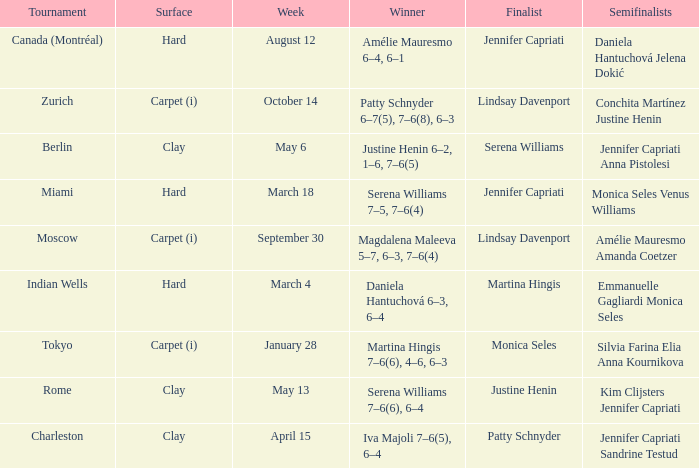What week was the finalist Martina Hingis? March 4. 